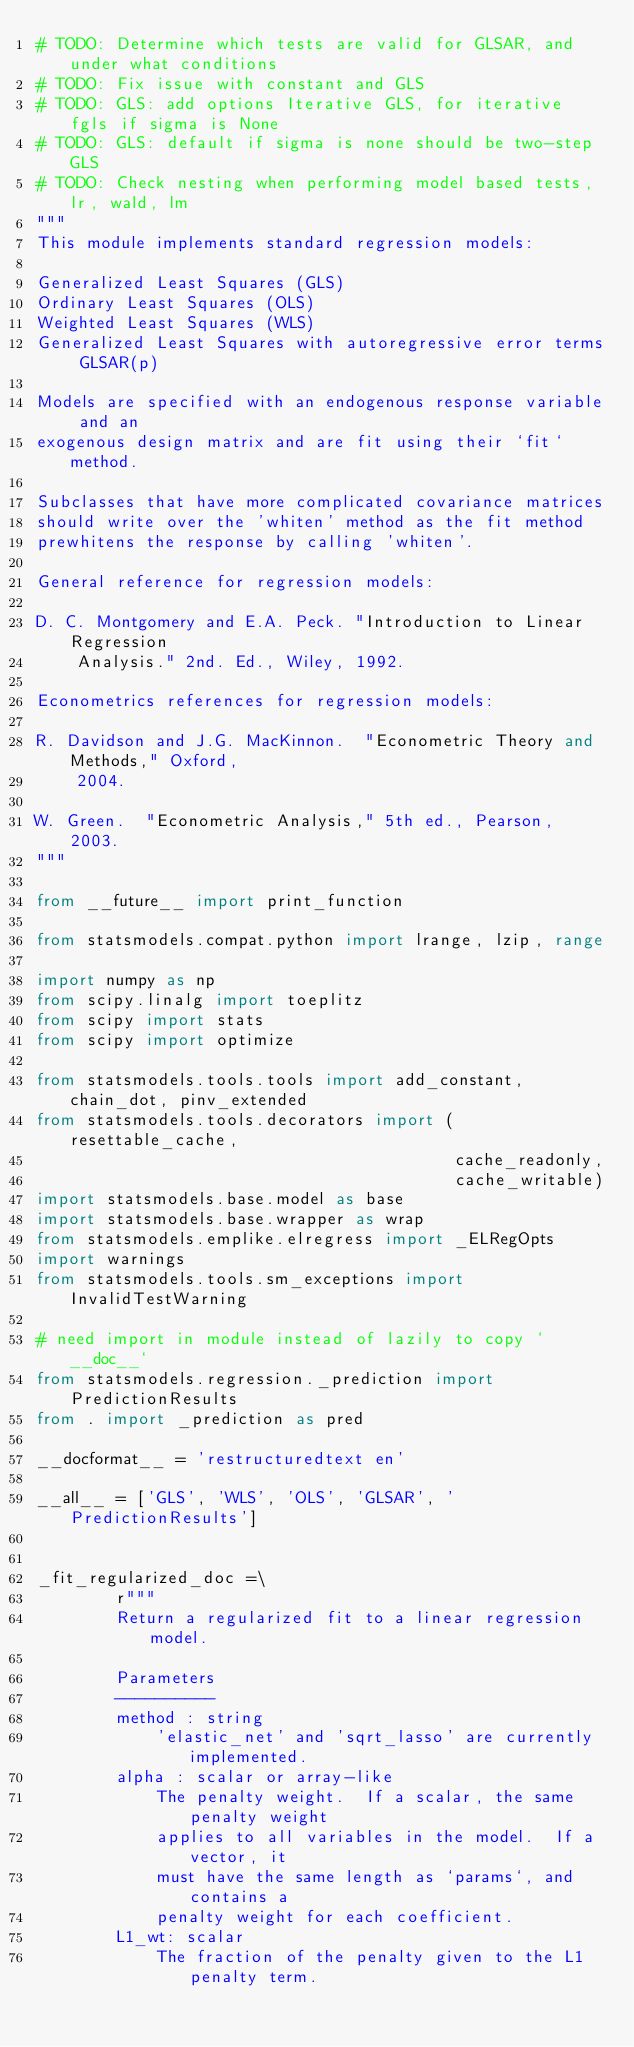Convert code to text. <code><loc_0><loc_0><loc_500><loc_500><_Python_># TODO: Determine which tests are valid for GLSAR, and under what conditions
# TODO: Fix issue with constant and GLS
# TODO: GLS: add options Iterative GLS, for iterative fgls if sigma is None
# TODO: GLS: default if sigma is none should be two-step GLS
# TODO: Check nesting when performing model based tests, lr, wald, lm
"""
This module implements standard regression models:

Generalized Least Squares (GLS)
Ordinary Least Squares (OLS)
Weighted Least Squares (WLS)
Generalized Least Squares with autoregressive error terms GLSAR(p)

Models are specified with an endogenous response variable and an
exogenous design matrix and are fit using their `fit` method.

Subclasses that have more complicated covariance matrices
should write over the 'whiten' method as the fit method
prewhitens the response by calling 'whiten'.

General reference for regression models:

D. C. Montgomery and E.A. Peck. "Introduction to Linear Regression
    Analysis." 2nd. Ed., Wiley, 1992.

Econometrics references for regression models:

R. Davidson and J.G. MacKinnon.  "Econometric Theory and Methods," Oxford,
    2004.

W. Green.  "Econometric Analysis," 5th ed., Pearson, 2003.
"""

from __future__ import print_function

from statsmodels.compat.python import lrange, lzip, range

import numpy as np
from scipy.linalg import toeplitz
from scipy import stats
from scipy import optimize

from statsmodels.tools.tools import add_constant, chain_dot, pinv_extended
from statsmodels.tools.decorators import (resettable_cache,
                                          cache_readonly,
                                          cache_writable)
import statsmodels.base.model as base
import statsmodels.base.wrapper as wrap
from statsmodels.emplike.elregress import _ELRegOpts
import warnings
from statsmodels.tools.sm_exceptions import InvalidTestWarning

# need import in module instead of lazily to copy `__doc__`
from statsmodels.regression._prediction import PredictionResults
from . import _prediction as pred

__docformat__ = 'restructuredtext en'

__all__ = ['GLS', 'WLS', 'OLS', 'GLSAR', 'PredictionResults']


_fit_regularized_doc =\
        r"""
        Return a regularized fit to a linear regression model.

        Parameters
        ----------
        method : string
            'elastic_net' and 'sqrt_lasso' are currently implemented.
        alpha : scalar or array-like
            The penalty weight.  If a scalar, the same penalty weight
            applies to all variables in the model.  If a vector, it
            must have the same length as `params`, and contains a
            penalty weight for each coefficient.
        L1_wt: scalar
            The fraction of the penalty given to the L1 penalty term.</code> 